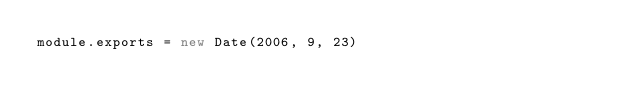<code> <loc_0><loc_0><loc_500><loc_500><_JavaScript_>module.exports = new Date(2006, 9, 23)
</code> 